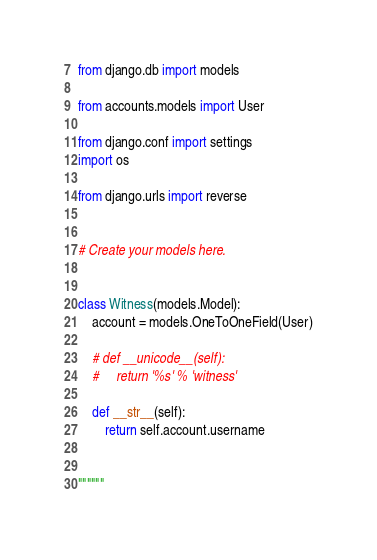<code> <loc_0><loc_0><loc_500><loc_500><_Python_>from django.db import models

from accounts.models import User

from django.conf import settings
import os

from django.urls import reverse


# Create your models here.


class Witness(models.Model):
    account = models.OneToOneField(User)

    # def __unicode__(self):
    #     return '%s' % 'witness'

    def __str__(self):
        return self.account.username


""""""
</code> 